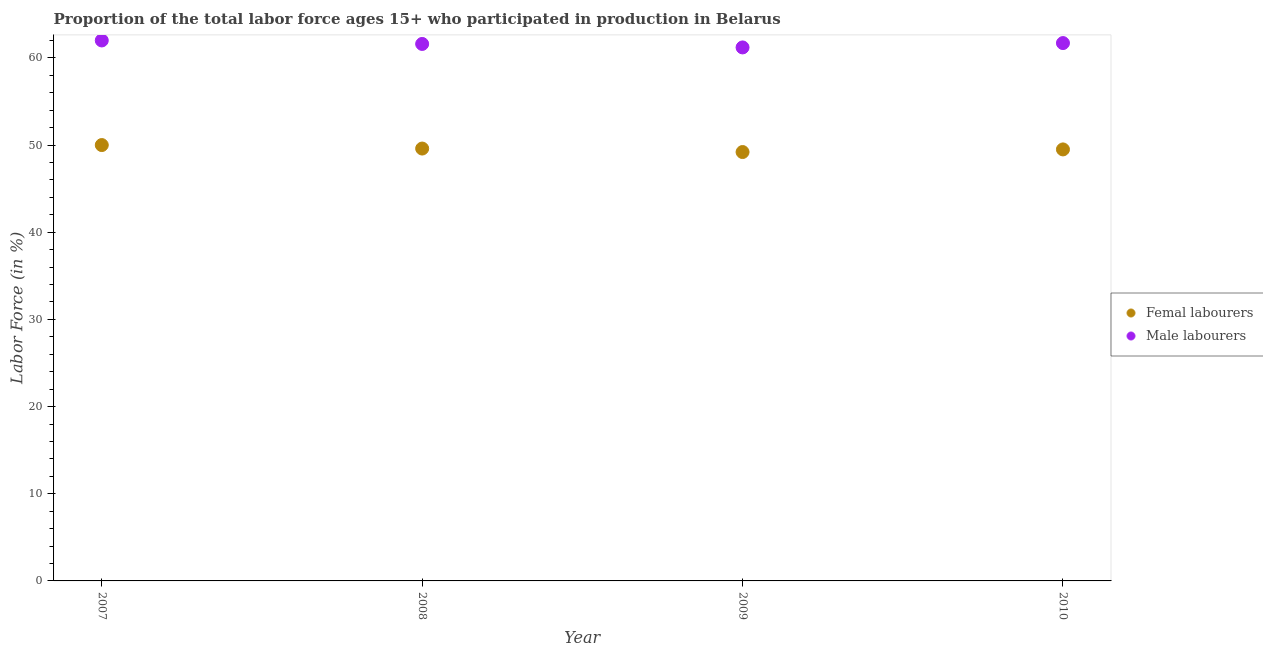Is the number of dotlines equal to the number of legend labels?
Give a very brief answer. Yes. What is the percentage of female labor force in 2009?
Your answer should be compact. 49.2. Across all years, what is the maximum percentage of male labour force?
Ensure brevity in your answer.  62. Across all years, what is the minimum percentage of male labour force?
Your answer should be compact. 61.2. In which year was the percentage of male labour force minimum?
Keep it short and to the point. 2009. What is the total percentage of female labor force in the graph?
Offer a terse response. 198.3. What is the difference between the percentage of female labor force in 2010 and the percentage of male labour force in 2009?
Your answer should be very brief. -11.7. What is the average percentage of female labor force per year?
Your response must be concise. 49.57. In the year 2009, what is the difference between the percentage of male labour force and percentage of female labor force?
Provide a succinct answer. 12. In how many years, is the percentage of female labor force greater than 34 %?
Offer a very short reply. 4. What is the ratio of the percentage of female labor force in 2009 to that in 2010?
Your response must be concise. 0.99. Is the percentage of male labour force in 2008 less than that in 2010?
Offer a terse response. Yes. What is the difference between the highest and the second highest percentage of female labor force?
Give a very brief answer. 0.4. What is the difference between the highest and the lowest percentage of male labour force?
Your response must be concise. 0.8. In how many years, is the percentage of male labour force greater than the average percentage of male labour force taken over all years?
Provide a short and direct response. 2. Is the percentage of male labour force strictly greater than the percentage of female labor force over the years?
Give a very brief answer. Yes. What is the difference between two consecutive major ticks on the Y-axis?
Give a very brief answer. 10. Are the values on the major ticks of Y-axis written in scientific E-notation?
Keep it short and to the point. No. Does the graph contain grids?
Keep it short and to the point. No. What is the title of the graph?
Give a very brief answer. Proportion of the total labor force ages 15+ who participated in production in Belarus. What is the label or title of the X-axis?
Provide a succinct answer. Year. What is the label or title of the Y-axis?
Provide a succinct answer. Labor Force (in %). What is the Labor Force (in %) of Male labourers in 2007?
Offer a terse response. 62. What is the Labor Force (in %) in Femal labourers in 2008?
Offer a very short reply. 49.6. What is the Labor Force (in %) in Male labourers in 2008?
Provide a succinct answer. 61.6. What is the Labor Force (in %) in Femal labourers in 2009?
Give a very brief answer. 49.2. What is the Labor Force (in %) in Male labourers in 2009?
Your answer should be very brief. 61.2. What is the Labor Force (in %) in Femal labourers in 2010?
Give a very brief answer. 49.5. What is the Labor Force (in %) of Male labourers in 2010?
Provide a succinct answer. 61.7. Across all years, what is the minimum Labor Force (in %) of Femal labourers?
Provide a short and direct response. 49.2. Across all years, what is the minimum Labor Force (in %) of Male labourers?
Your answer should be very brief. 61.2. What is the total Labor Force (in %) of Femal labourers in the graph?
Your response must be concise. 198.3. What is the total Labor Force (in %) in Male labourers in the graph?
Keep it short and to the point. 246.5. What is the difference between the Labor Force (in %) of Femal labourers in 2007 and that in 2008?
Give a very brief answer. 0.4. What is the difference between the Labor Force (in %) of Male labourers in 2007 and that in 2008?
Provide a short and direct response. 0.4. What is the difference between the Labor Force (in %) of Femal labourers in 2007 and that in 2009?
Your response must be concise. 0.8. What is the difference between the Labor Force (in %) of Male labourers in 2007 and that in 2009?
Give a very brief answer. 0.8. What is the difference between the Labor Force (in %) of Femal labourers in 2008 and that in 2009?
Offer a very short reply. 0.4. What is the difference between the Labor Force (in %) in Male labourers in 2008 and that in 2009?
Ensure brevity in your answer.  0.4. What is the difference between the Labor Force (in %) in Femal labourers in 2008 and that in 2010?
Offer a very short reply. 0.1. What is the difference between the Labor Force (in %) in Male labourers in 2008 and that in 2010?
Your response must be concise. -0.1. What is the difference between the Labor Force (in %) in Femal labourers in 2009 and that in 2010?
Provide a short and direct response. -0.3. What is the difference between the Labor Force (in %) in Male labourers in 2009 and that in 2010?
Your response must be concise. -0.5. What is the difference between the Labor Force (in %) in Femal labourers in 2007 and the Labor Force (in %) in Male labourers in 2008?
Offer a terse response. -11.6. What is the difference between the Labor Force (in %) of Femal labourers in 2008 and the Labor Force (in %) of Male labourers in 2010?
Ensure brevity in your answer.  -12.1. What is the average Labor Force (in %) of Femal labourers per year?
Your answer should be compact. 49.58. What is the average Labor Force (in %) in Male labourers per year?
Provide a succinct answer. 61.62. In the year 2007, what is the difference between the Labor Force (in %) in Femal labourers and Labor Force (in %) in Male labourers?
Your answer should be very brief. -12. In the year 2008, what is the difference between the Labor Force (in %) in Femal labourers and Labor Force (in %) in Male labourers?
Offer a terse response. -12. In the year 2009, what is the difference between the Labor Force (in %) in Femal labourers and Labor Force (in %) in Male labourers?
Your answer should be compact. -12. In the year 2010, what is the difference between the Labor Force (in %) of Femal labourers and Labor Force (in %) of Male labourers?
Provide a succinct answer. -12.2. What is the ratio of the Labor Force (in %) in Femal labourers in 2007 to that in 2008?
Your answer should be compact. 1.01. What is the ratio of the Labor Force (in %) in Male labourers in 2007 to that in 2008?
Your response must be concise. 1.01. What is the ratio of the Labor Force (in %) in Femal labourers in 2007 to that in 2009?
Keep it short and to the point. 1.02. What is the ratio of the Labor Force (in %) of Male labourers in 2007 to that in 2009?
Ensure brevity in your answer.  1.01. What is the ratio of the Labor Force (in %) of Male labourers in 2007 to that in 2010?
Your answer should be very brief. 1. What is the ratio of the Labor Force (in %) in Male labourers in 2008 to that in 2009?
Give a very brief answer. 1.01. What is the ratio of the Labor Force (in %) in Male labourers in 2009 to that in 2010?
Ensure brevity in your answer.  0.99. What is the difference between the highest and the second highest Labor Force (in %) in Femal labourers?
Keep it short and to the point. 0.4. What is the difference between the highest and the lowest Labor Force (in %) in Femal labourers?
Keep it short and to the point. 0.8. What is the difference between the highest and the lowest Labor Force (in %) of Male labourers?
Offer a very short reply. 0.8. 